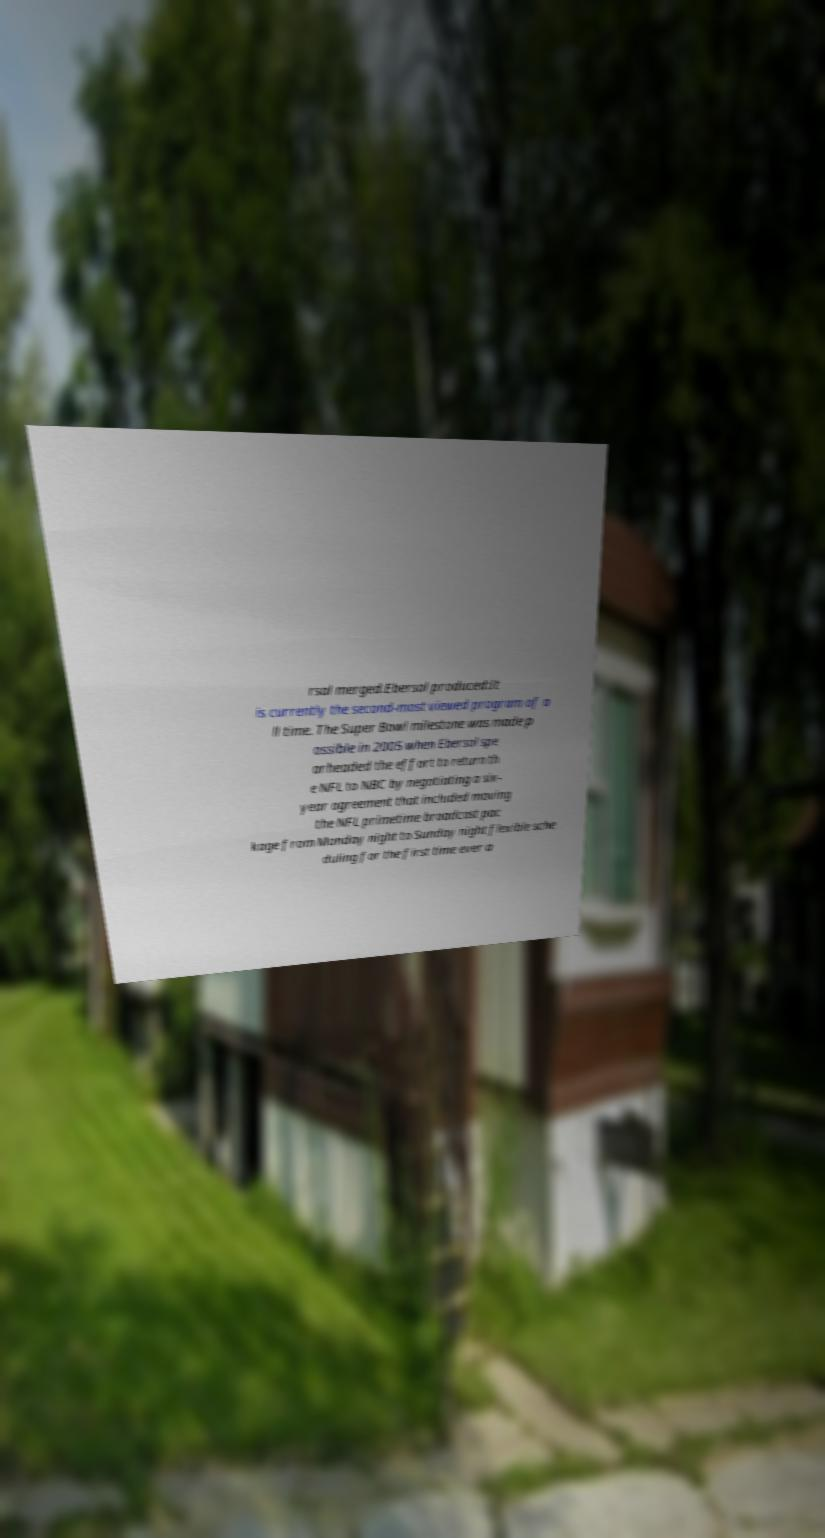I need the written content from this picture converted into text. Can you do that? rsal merged.Ebersol produced:It is currently the second-most viewed program of a ll time. The Super Bowl milestone was made p ossible in 2005 when Ebersol spe arheaded the effort to return th e NFL to NBC by negotiating a six- year agreement that included moving the NFL primetime broadcast pac kage from Monday night to Sunday night flexible sche duling for the first time ever a 